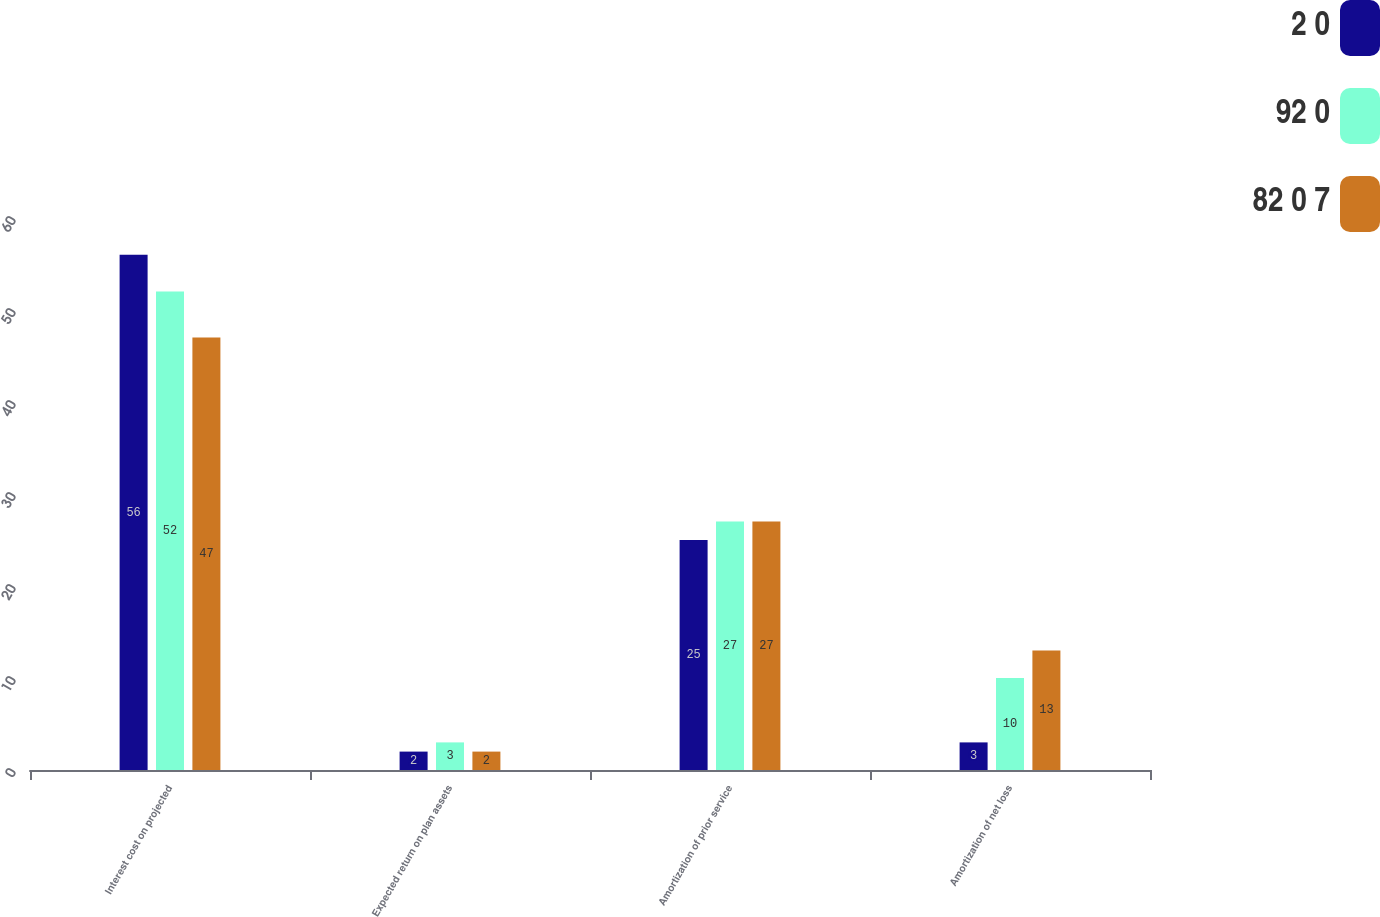Convert chart. <chart><loc_0><loc_0><loc_500><loc_500><stacked_bar_chart><ecel><fcel>Interest cost on projected<fcel>Expected return on plan assets<fcel>Amortization of prior service<fcel>Amortization of net loss<nl><fcel>2 0<fcel>56<fcel>2<fcel>25<fcel>3<nl><fcel>92 0<fcel>52<fcel>3<fcel>27<fcel>10<nl><fcel>82 0 7<fcel>47<fcel>2<fcel>27<fcel>13<nl></chart> 